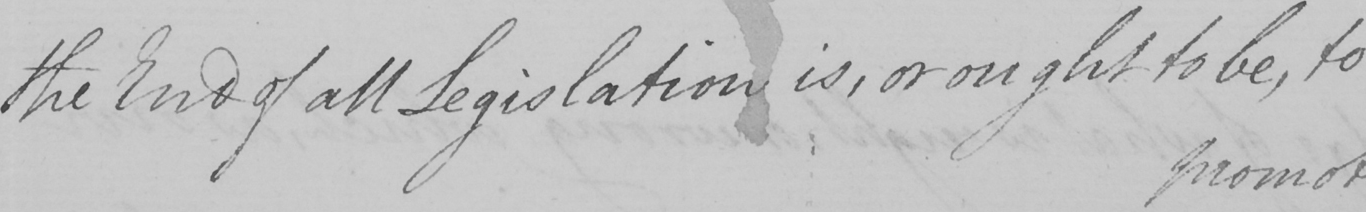What text is written in this handwritten line? the End of all Legislation is , or ought to be , to 